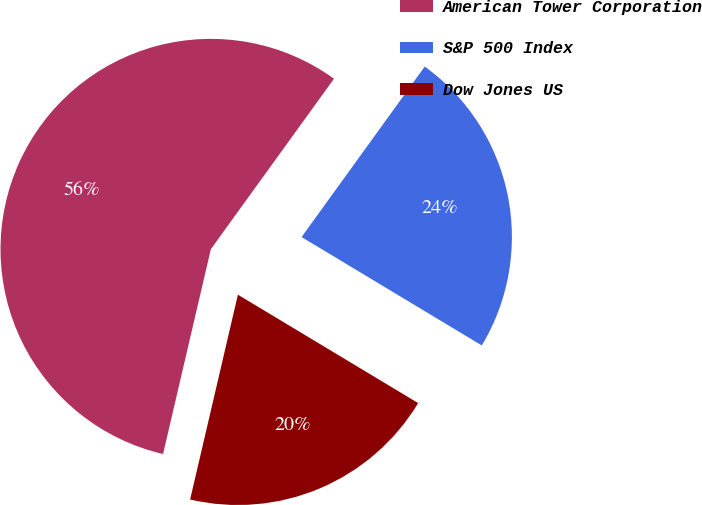<chart> <loc_0><loc_0><loc_500><loc_500><pie_chart><fcel>American Tower Corporation<fcel>S&P 500 Index<fcel>Dow Jones US<nl><fcel>56.31%<fcel>23.66%<fcel>20.03%<nl></chart> 